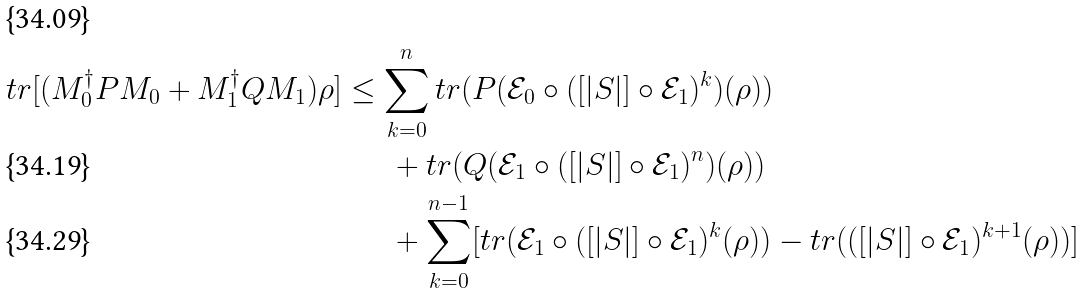<formula> <loc_0><loc_0><loc_500><loc_500>t r [ ( M _ { 0 } ^ { \dag } P M _ { 0 } + M _ { 1 } ^ { \dag } Q M _ { 1 } ) \rho ] & \leq \sum _ { k = 0 } ^ { n } t r ( P ( \mathcal { E } _ { 0 } \circ ( [ | S | ] \circ \mathcal { E } _ { 1 } ) ^ { k } ) ( \rho ) ) \\ & \quad \ \ + t r ( Q ( \mathcal { E } _ { 1 } \circ ( [ | S | ] \circ \mathcal { E } _ { 1 } ) ^ { n } ) ( \rho ) ) \\ & \quad \ \ + \sum _ { k = 0 } ^ { n - 1 } [ t r ( \mathcal { E } _ { 1 } \circ ( [ | S | ] \circ \mathcal { E } _ { 1 } ) ^ { k } ( \rho ) ) - t r ( ( [ | S | ] \circ \mathcal { E } _ { 1 } ) ^ { k + 1 } ( \rho ) ) ]</formula> 